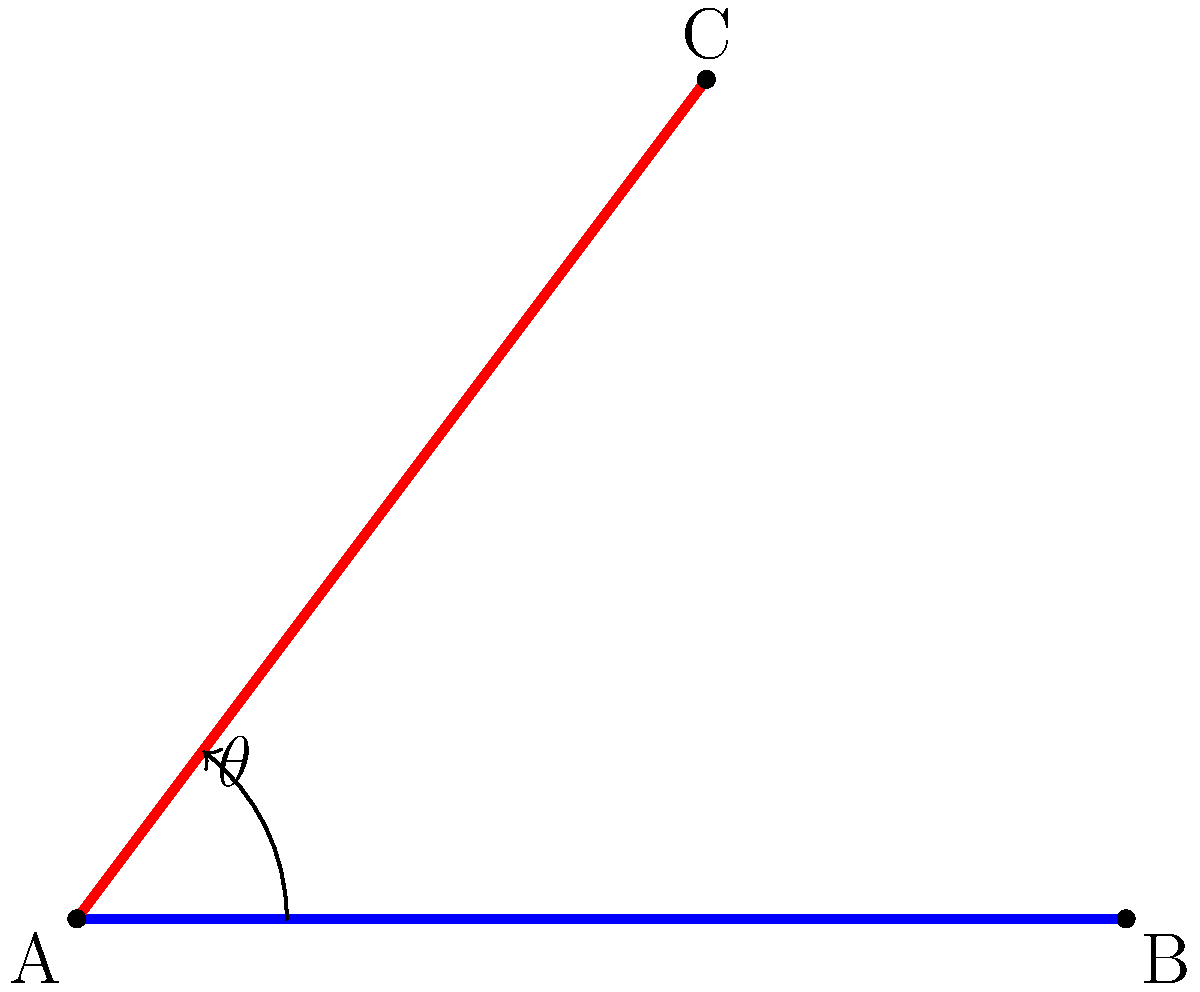In Vincent van Gogh's "Starry Night," two prominent brushstrokes intersect to form a striking angle. If we represent these brushstrokes as line segments AB and AC in the diagram, what is the measure of angle $\theta$ formed between them? To find the angle between the two brushstrokes, we can use the properties of right triangles and the arctangent function. Let's approach this step-by-step:

1. We can treat the blue line (AB) as our x-axis and the red line (AC) as our hypotenuse in a right triangle.

2. The angle $\theta$ is formed between these two lines.

3. In the right triangle formed, we know:
   - The base (adjacent side) is 60 units long
   - The height (opposite side) is 80 units long

4. We can use the arctangent function to find the angle:

   $\theta = \arctan(\frac{\text{opposite}}{\text{adjacent}})$

5. Plugging in our values:

   $\theta = \arctan(\frac{80}{60})$

6. Simplifying:

   $\theta = \arctan(\frac{4}{3})$

7. Using a calculator or trigonometric tables:

   $\theta \approx 53.13°$

This angle represents the dynamic interplay between brushstrokes in van Gogh's masterpiece, reflecting the turbulent energy often associated with his work.
Answer: $53.13°$ 